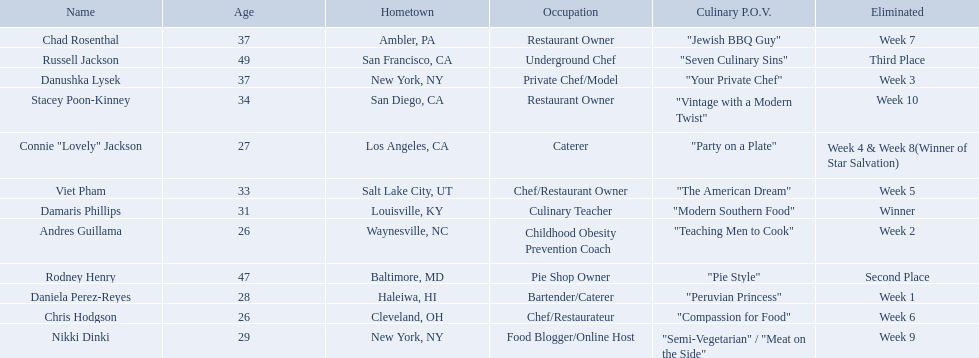Excluding the winner, and second and third place winners, who were the contestants eliminated? Stacey Poon-Kinney, Nikki Dinki, Chad Rosenthal, Chris Hodgson, Viet Pham, Connie "Lovely" Jackson, Danushka Lysek, Andres Guillama, Daniela Perez-Reyes. Of these contestants, who were the last five eliminated before the winner, second, and third place winners were announce? Stacey Poon-Kinney, Nikki Dinki, Chad Rosenthal, Chris Hodgson, Viet Pham. Of these five contestants, was nikki dinki or viet pham eliminated first? Viet Pham. 